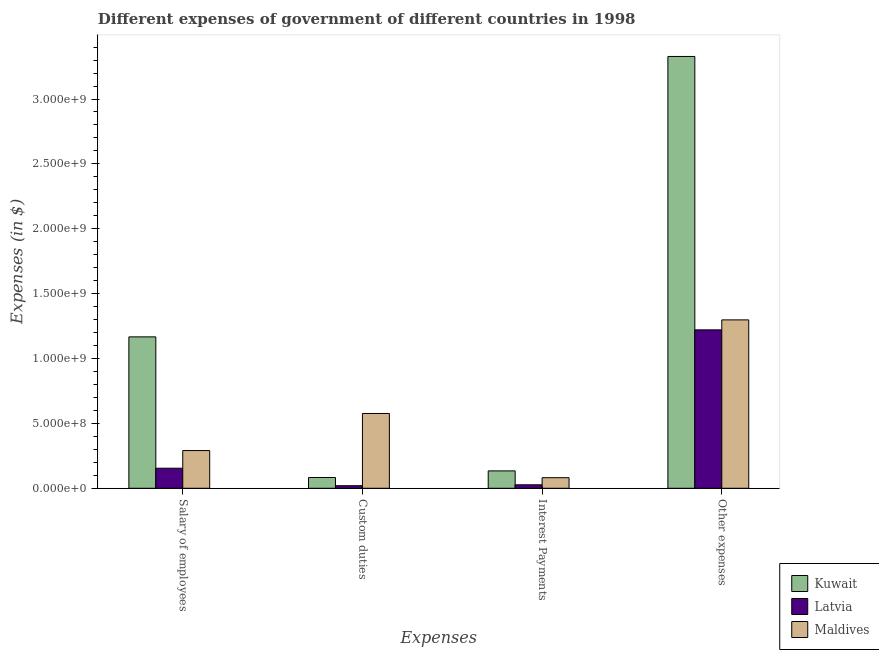How many groups of bars are there?
Offer a terse response. 4. Are the number of bars on each tick of the X-axis equal?
Provide a succinct answer. Yes. What is the label of the 3rd group of bars from the left?
Provide a succinct answer. Interest Payments. What is the amount spent on custom duties in Kuwait?
Provide a succinct answer. 8.30e+07. Across all countries, what is the maximum amount spent on other expenses?
Provide a short and direct response. 3.33e+09. Across all countries, what is the minimum amount spent on other expenses?
Ensure brevity in your answer.  1.22e+09. In which country was the amount spent on salary of employees maximum?
Make the answer very short. Kuwait. In which country was the amount spent on salary of employees minimum?
Provide a succinct answer. Latvia. What is the total amount spent on salary of employees in the graph?
Your response must be concise. 1.61e+09. What is the difference between the amount spent on custom duties in Maldives and that in Latvia?
Give a very brief answer. 5.57e+08. What is the difference between the amount spent on interest payments in Latvia and the amount spent on custom duties in Maldives?
Provide a succinct answer. -5.50e+08. What is the average amount spent on other expenses per country?
Give a very brief answer. 1.95e+09. What is the difference between the amount spent on salary of employees and amount spent on other expenses in Kuwait?
Your response must be concise. -2.16e+09. In how many countries, is the amount spent on salary of employees greater than 2200000000 $?
Give a very brief answer. 0. What is the ratio of the amount spent on custom duties in Kuwait to that in Maldives?
Your response must be concise. 0.14. What is the difference between the highest and the second highest amount spent on salary of employees?
Offer a terse response. 8.76e+08. What is the difference between the highest and the lowest amount spent on interest payments?
Offer a terse response. 1.07e+08. In how many countries, is the amount spent on other expenses greater than the average amount spent on other expenses taken over all countries?
Keep it short and to the point. 1. Is the sum of the amount spent on custom duties in Kuwait and Maldives greater than the maximum amount spent on interest payments across all countries?
Make the answer very short. Yes. Is it the case that in every country, the sum of the amount spent on salary of employees and amount spent on interest payments is greater than the sum of amount spent on custom duties and amount spent on other expenses?
Ensure brevity in your answer.  No. What does the 2nd bar from the left in Interest Payments represents?
Provide a succinct answer. Latvia. What does the 2nd bar from the right in Other expenses represents?
Provide a short and direct response. Latvia. Is it the case that in every country, the sum of the amount spent on salary of employees and amount spent on custom duties is greater than the amount spent on interest payments?
Your answer should be very brief. Yes. Are all the bars in the graph horizontal?
Your response must be concise. No. Does the graph contain grids?
Your answer should be very brief. No. Where does the legend appear in the graph?
Keep it short and to the point. Bottom right. What is the title of the graph?
Provide a succinct answer. Different expenses of government of different countries in 1998. What is the label or title of the X-axis?
Your answer should be compact. Expenses. What is the label or title of the Y-axis?
Provide a short and direct response. Expenses (in $). What is the Expenses (in $) of Kuwait in Salary of employees?
Your answer should be very brief. 1.17e+09. What is the Expenses (in $) in Latvia in Salary of employees?
Offer a very short reply. 1.55e+08. What is the Expenses (in $) of Maldives in Salary of employees?
Your answer should be very brief. 2.91e+08. What is the Expenses (in $) of Kuwait in Custom duties?
Offer a very short reply. 8.30e+07. What is the Expenses (in $) of Latvia in Custom duties?
Ensure brevity in your answer.  1.98e+07. What is the Expenses (in $) of Maldives in Custom duties?
Offer a terse response. 5.76e+08. What is the Expenses (in $) in Kuwait in Interest Payments?
Your response must be concise. 1.34e+08. What is the Expenses (in $) of Latvia in Interest Payments?
Give a very brief answer. 2.67e+07. What is the Expenses (in $) of Maldives in Interest Payments?
Provide a succinct answer. 8.16e+07. What is the Expenses (in $) of Kuwait in Other expenses?
Ensure brevity in your answer.  3.33e+09. What is the Expenses (in $) of Latvia in Other expenses?
Keep it short and to the point. 1.22e+09. What is the Expenses (in $) of Maldives in Other expenses?
Give a very brief answer. 1.30e+09. Across all Expenses, what is the maximum Expenses (in $) of Kuwait?
Offer a very short reply. 3.33e+09. Across all Expenses, what is the maximum Expenses (in $) of Latvia?
Provide a short and direct response. 1.22e+09. Across all Expenses, what is the maximum Expenses (in $) in Maldives?
Give a very brief answer. 1.30e+09. Across all Expenses, what is the minimum Expenses (in $) of Kuwait?
Offer a terse response. 8.30e+07. Across all Expenses, what is the minimum Expenses (in $) of Latvia?
Keep it short and to the point. 1.98e+07. Across all Expenses, what is the minimum Expenses (in $) in Maldives?
Provide a short and direct response. 8.16e+07. What is the total Expenses (in $) of Kuwait in the graph?
Ensure brevity in your answer.  4.71e+09. What is the total Expenses (in $) in Latvia in the graph?
Provide a short and direct response. 1.42e+09. What is the total Expenses (in $) in Maldives in the graph?
Your response must be concise. 2.25e+09. What is the difference between the Expenses (in $) in Kuwait in Salary of employees and that in Custom duties?
Keep it short and to the point. 1.08e+09. What is the difference between the Expenses (in $) of Latvia in Salary of employees and that in Custom duties?
Offer a very short reply. 1.35e+08. What is the difference between the Expenses (in $) of Maldives in Salary of employees and that in Custom duties?
Your answer should be compact. -2.86e+08. What is the difference between the Expenses (in $) of Kuwait in Salary of employees and that in Interest Payments?
Offer a very short reply. 1.03e+09. What is the difference between the Expenses (in $) of Latvia in Salary of employees and that in Interest Payments?
Your response must be concise. 1.28e+08. What is the difference between the Expenses (in $) of Maldives in Salary of employees and that in Interest Payments?
Make the answer very short. 2.09e+08. What is the difference between the Expenses (in $) in Kuwait in Salary of employees and that in Other expenses?
Provide a short and direct response. -2.16e+09. What is the difference between the Expenses (in $) of Latvia in Salary of employees and that in Other expenses?
Offer a terse response. -1.07e+09. What is the difference between the Expenses (in $) of Maldives in Salary of employees and that in Other expenses?
Your answer should be very brief. -1.01e+09. What is the difference between the Expenses (in $) in Kuwait in Custom duties and that in Interest Payments?
Your response must be concise. -5.10e+07. What is the difference between the Expenses (in $) of Latvia in Custom duties and that in Interest Payments?
Keep it short and to the point. -6.99e+06. What is the difference between the Expenses (in $) in Maldives in Custom duties and that in Interest Payments?
Offer a very short reply. 4.95e+08. What is the difference between the Expenses (in $) in Kuwait in Custom duties and that in Other expenses?
Offer a terse response. -3.24e+09. What is the difference between the Expenses (in $) in Latvia in Custom duties and that in Other expenses?
Your answer should be compact. -1.20e+09. What is the difference between the Expenses (in $) of Maldives in Custom duties and that in Other expenses?
Provide a succinct answer. -7.21e+08. What is the difference between the Expenses (in $) in Kuwait in Interest Payments and that in Other expenses?
Offer a terse response. -3.19e+09. What is the difference between the Expenses (in $) in Latvia in Interest Payments and that in Other expenses?
Keep it short and to the point. -1.19e+09. What is the difference between the Expenses (in $) of Maldives in Interest Payments and that in Other expenses?
Make the answer very short. -1.22e+09. What is the difference between the Expenses (in $) of Kuwait in Salary of employees and the Expenses (in $) of Latvia in Custom duties?
Provide a short and direct response. 1.15e+09. What is the difference between the Expenses (in $) in Kuwait in Salary of employees and the Expenses (in $) in Maldives in Custom duties?
Provide a succinct answer. 5.90e+08. What is the difference between the Expenses (in $) of Latvia in Salary of employees and the Expenses (in $) of Maldives in Custom duties?
Your answer should be compact. -4.22e+08. What is the difference between the Expenses (in $) of Kuwait in Salary of employees and the Expenses (in $) of Latvia in Interest Payments?
Your answer should be very brief. 1.14e+09. What is the difference between the Expenses (in $) in Kuwait in Salary of employees and the Expenses (in $) in Maldives in Interest Payments?
Your answer should be compact. 1.09e+09. What is the difference between the Expenses (in $) of Latvia in Salary of employees and the Expenses (in $) of Maldives in Interest Payments?
Your answer should be very brief. 7.30e+07. What is the difference between the Expenses (in $) in Kuwait in Salary of employees and the Expenses (in $) in Latvia in Other expenses?
Your answer should be compact. -5.40e+07. What is the difference between the Expenses (in $) in Kuwait in Salary of employees and the Expenses (in $) in Maldives in Other expenses?
Provide a succinct answer. -1.31e+08. What is the difference between the Expenses (in $) in Latvia in Salary of employees and the Expenses (in $) in Maldives in Other expenses?
Offer a very short reply. -1.14e+09. What is the difference between the Expenses (in $) of Kuwait in Custom duties and the Expenses (in $) of Latvia in Interest Payments?
Your answer should be compact. 5.63e+07. What is the difference between the Expenses (in $) of Kuwait in Custom duties and the Expenses (in $) of Maldives in Interest Payments?
Keep it short and to the point. 1.40e+06. What is the difference between the Expenses (in $) of Latvia in Custom duties and the Expenses (in $) of Maldives in Interest Payments?
Give a very brief answer. -6.18e+07. What is the difference between the Expenses (in $) of Kuwait in Custom duties and the Expenses (in $) of Latvia in Other expenses?
Offer a terse response. -1.14e+09. What is the difference between the Expenses (in $) of Kuwait in Custom duties and the Expenses (in $) of Maldives in Other expenses?
Offer a very short reply. -1.21e+09. What is the difference between the Expenses (in $) of Latvia in Custom duties and the Expenses (in $) of Maldives in Other expenses?
Keep it short and to the point. -1.28e+09. What is the difference between the Expenses (in $) of Kuwait in Interest Payments and the Expenses (in $) of Latvia in Other expenses?
Provide a short and direct response. -1.09e+09. What is the difference between the Expenses (in $) of Kuwait in Interest Payments and the Expenses (in $) of Maldives in Other expenses?
Give a very brief answer. -1.16e+09. What is the difference between the Expenses (in $) in Latvia in Interest Payments and the Expenses (in $) in Maldives in Other expenses?
Offer a very short reply. -1.27e+09. What is the average Expenses (in $) of Kuwait per Expenses?
Your answer should be very brief. 1.18e+09. What is the average Expenses (in $) in Latvia per Expenses?
Give a very brief answer. 3.56e+08. What is the average Expenses (in $) of Maldives per Expenses?
Keep it short and to the point. 5.62e+08. What is the difference between the Expenses (in $) of Kuwait and Expenses (in $) of Latvia in Salary of employees?
Your answer should be compact. 1.01e+09. What is the difference between the Expenses (in $) of Kuwait and Expenses (in $) of Maldives in Salary of employees?
Provide a succinct answer. 8.76e+08. What is the difference between the Expenses (in $) of Latvia and Expenses (in $) of Maldives in Salary of employees?
Provide a succinct answer. -1.36e+08. What is the difference between the Expenses (in $) of Kuwait and Expenses (in $) of Latvia in Custom duties?
Your answer should be very brief. 6.32e+07. What is the difference between the Expenses (in $) of Kuwait and Expenses (in $) of Maldives in Custom duties?
Provide a succinct answer. -4.94e+08. What is the difference between the Expenses (in $) in Latvia and Expenses (in $) in Maldives in Custom duties?
Your answer should be very brief. -5.57e+08. What is the difference between the Expenses (in $) of Kuwait and Expenses (in $) of Latvia in Interest Payments?
Your answer should be very brief. 1.07e+08. What is the difference between the Expenses (in $) in Kuwait and Expenses (in $) in Maldives in Interest Payments?
Your answer should be very brief. 5.24e+07. What is the difference between the Expenses (in $) of Latvia and Expenses (in $) of Maldives in Interest Payments?
Your answer should be very brief. -5.49e+07. What is the difference between the Expenses (in $) in Kuwait and Expenses (in $) in Latvia in Other expenses?
Keep it short and to the point. 2.11e+09. What is the difference between the Expenses (in $) in Kuwait and Expenses (in $) in Maldives in Other expenses?
Your answer should be compact. 2.03e+09. What is the difference between the Expenses (in $) of Latvia and Expenses (in $) of Maldives in Other expenses?
Make the answer very short. -7.69e+07. What is the ratio of the Expenses (in $) in Kuwait in Salary of employees to that in Custom duties?
Your answer should be compact. 14.06. What is the ratio of the Expenses (in $) in Latvia in Salary of employees to that in Custom duties?
Ensure brevity in your answer.  7.83. What is the ratio of the Expenses (in $) in Maldives in Salary of employees to that in Custom duties?
Offer a terse response. 0.5. What is the ratio of the Expenses (in $) of Kuwait in Salary of employees to that in Interest Payments?
Keep it short and to the point. 8.71. What is the ratio of the Expenses (in $) in Latvia in Salary of employees to that in Interest Payments?
Offer a terse response. 5.78. What is the ratio of the Expenses (in $) in Maldives in Salary of employees to that in Interest Payments?
Make the answer very short. 3.56. What is the ratio of the Expenses (in $) in Kuwait in Salary of employees to that in Other expenses?
Your answer should be very brief. 0.35. What is the ratio of the Expenses (in $) in Latvia in Salary of employees to that in Other expenses?
Offer a very short reply. 0.13. What is the ratio of the Expenses (in $) of Maldives in Salary of employees to that in Other expenses?
Your answer should be very brief. 0.22. What is the ratio of the Expenses (in $) of Kuwait in Custom duties to that in Interest Payments?
Your answer should be very brief. 0.62. What is the ratio of the Expenses (in $) in Latvia in Custom duties to that in Interest Payments?
Your answer should be compact. 0.74. What is the ratio of the Expenses (in $) in Maldives in Custom duties to that in Interest Payments?
Keep it short and to the point. 7.07. What is the ratio of the Expenses (in $) of Kuwait in Custom duties to that in Other expenses?
Your answer should be very brief. 0.02. What is the ratio of the Expenses (in $) in Latvia in Custom duties to that in Other expenses?
Ensure brevity in your answer.  0.02. What is the ratio of the Expenses (in $) in Maldives in Custom duties to that in Other expenses?
Provide a short and direct response. 0.44. What is the ratio of the Expenses (in $) of Kuwait in Interest Payments to that in Other expenses?
Make the answer very short. 0.04. What is the ratio of the Expenses (in $) in Latvia in Interest Payments to that in Other expenses?
Your answer should be compact. 0.02. What is the ratio of the Expenses (in $) of Maldives in Interest Payments to that in Other expenses?
Give a very brief answer. 0.06. What is the difference between the highest and the second highest Expenses (in $) of Kuwait?
Ensure brevity in your answer.  2.16e+09. What is the difference between the highest and the second highest Expenses (in $) of Latvia?
Give a very brief answer. 1.07e+09. What is the difference between the highest and the second highest Expenses (in $) in Maldives?
Keep it short and to the point. 7.21e+08. What is the difference between the highest and the lowest Expenses (in $) of Kuwait?
Provide a succinct answer. 3.24e+09. What is the difference between the highest and the lowest Expenses (in $) in Latvia?
Provide a succinct answer. 1.20e+09. What is the difference between the highest and the lowest Expenses (in $) of Maldives?
Your response must be concise. 1.22e+09. 